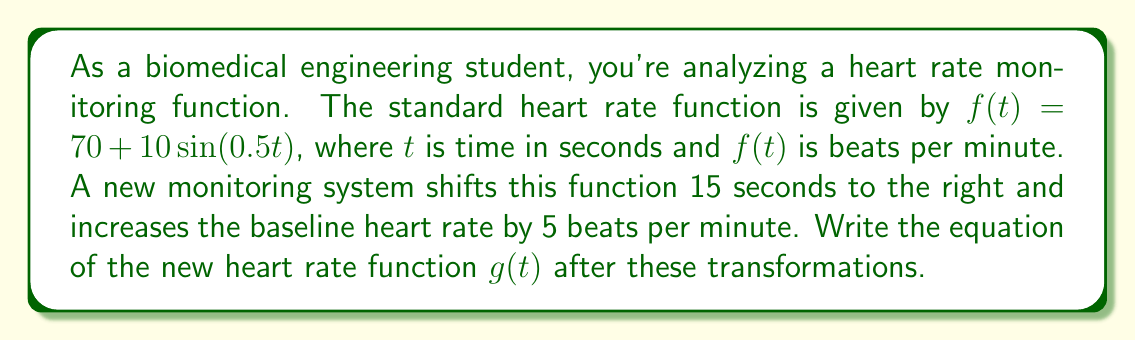Could you help me with this problem? To solve this problem, we need to apply the vertical and horizontal shift transformations to the original function $f(t) = 70 + 10\sin(0.5t)$.

1. Horizontal shift:
   The function is shifted 15 seconds to the right. For a horizontal shift of $h$ units right, we replace $t$ with $(t-h)$ in the original function.
   In this case, $h = 15$, so we replace $t$ with $(t-15)$.

2. Vertical shift:
   The baseline heart rate is increased by 5 beats per minute. This is a vertical shift up by 5 units.
   For a vertical shift of $k$ units up, we add $k$ to the entire function.
   In this case, $k = 5$.

Applying both transformations:

1. Replace $t$ with $(t-15)$ in the sine function:
   $g(t) = 70 + 10\sin(0.5(t-15)) + 5$

2. Simplify:
   $g(t) = 75 + 10\sin(0.5t - 7.5)$

Therefore, the new heart rate function after the transformations is:
$$g(t) = 75 + 10\sin(0.5t - 7.5)$$

This function represents a heart rate that oscillates around a baseline of 75 beats per minute (increased from 70), with the same amplitude of 10 beats per minute, but shifted 15 seconds to the right in time.
Answer: $g(t) = 75 + 10\sin(0.5t - 7.5)$ 